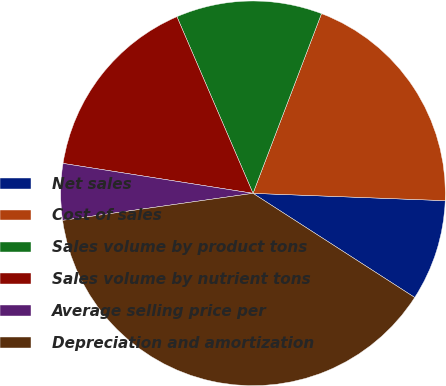Convert chart to OTSL. <chart><loc_0><loc_0><loc_500><loc_500><pie_chart><fcel>Net sales<fcel>Cost of sales<fcel>Sales volume by product tons<fcel>Sales volume by nutrient tons<fcel>Average selling price per<fcel>Depreciation and amortization<nl><fcel>8.5%<fcel>19.81%<fcel>12.27%<fcel>16.04%<fcel>4.73%<fcel>38.65%<nl></chart> 